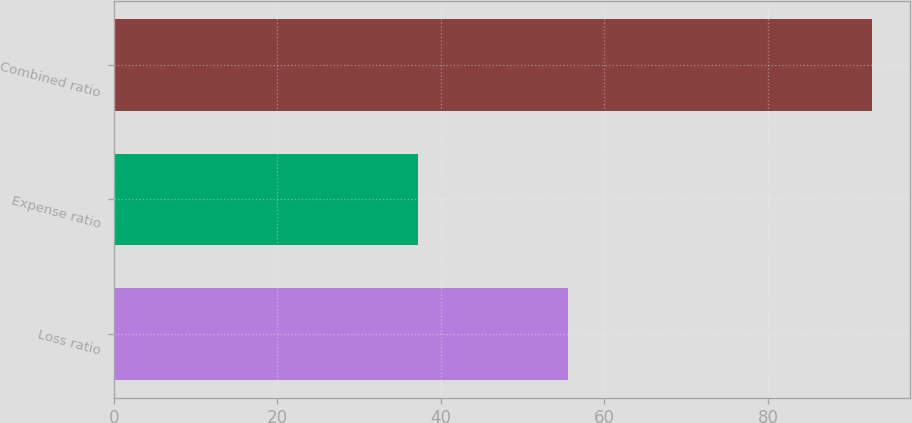Convert chart to OTSL. <chart><loc_0><loc_0><loc_500><loc_500><bar_chart><fcel>Loss ratio<fcel>Expense ratio<fcel>Combined ratio<nl><fcel>55.5<fcel>37.2<fcel>92.7<nl></chart> 